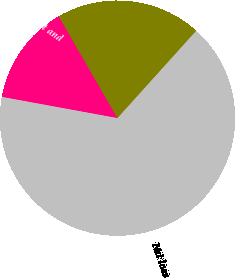Convert chart. <chart><loc_0><loc_0><loc_500><loc_500><pie_chart><fcel>Research development and<fcel>Income before equity earnings<fcel>Net loss<nl><fcel>13.79%<fcel>20.0%<fcel>66.21%<nl></chart> 